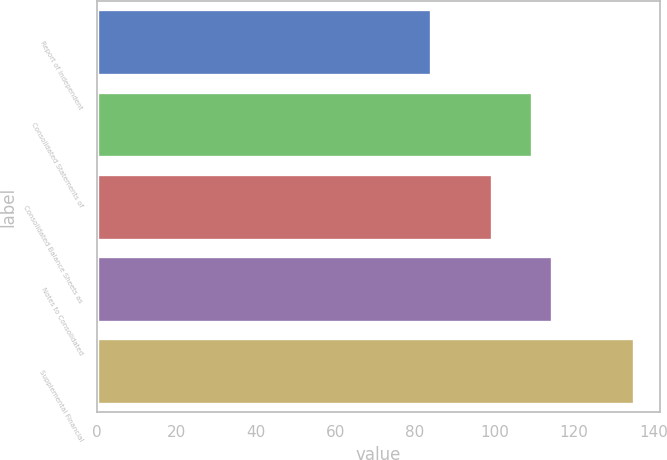<chart> <loc_0><loc_0><loc_500><loc_500><bar_chart><fcel>Report of Independent<fcel>Consolidated Statements of<fcel>Consolidated Balance Sheets as<fcel>Notes to Consolidated<fcel>Supplemental Financial<nl><fcel>84<fcel>109.5<fcel>99.3<fcel>114.6<fcel>135<nl></chart> 